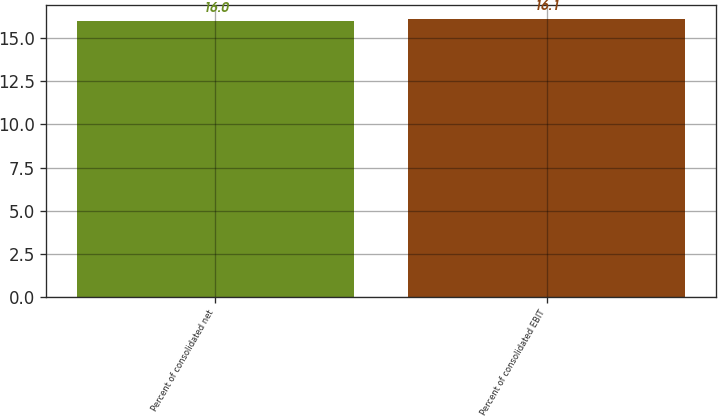<chart> <loc_0><loc_0><loc_500><loc_500><bar_chart><fcel>Percent of consolidated net<fcel>Percent of consolidated EBIT<nl><fcel>16<fcel>16.1<nl></chart> 